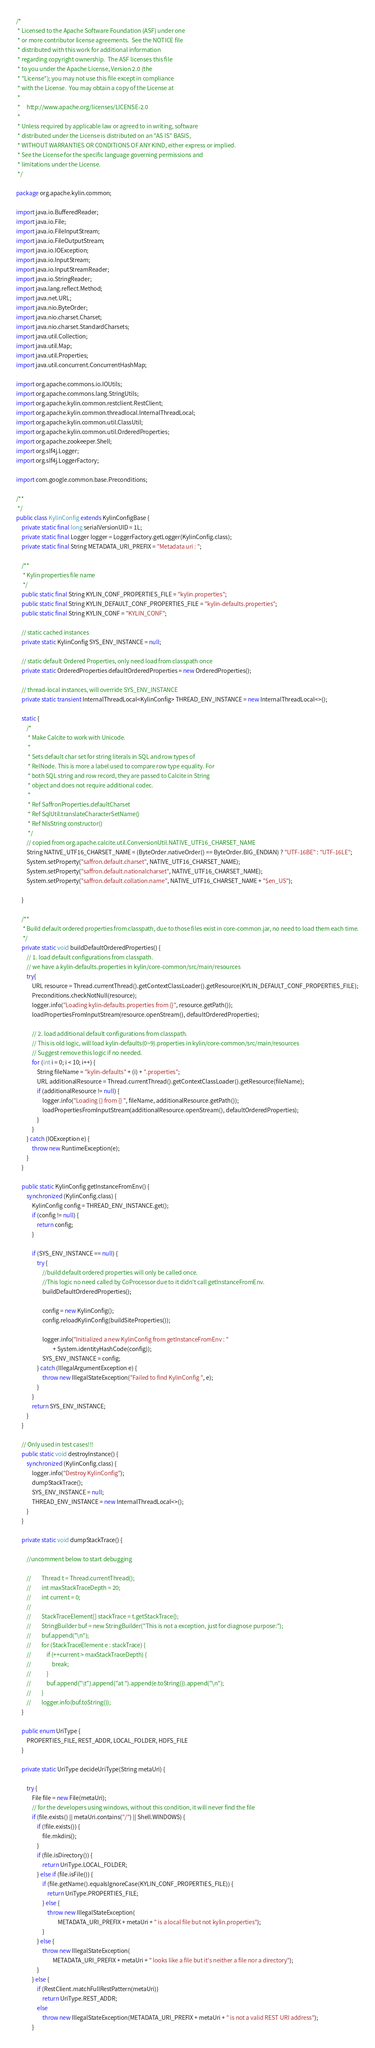<code> <loc_0><loc_0><loc_500><loc_500><_Java_>/*
 * Licensed to the Apache Software Foundation (ASF) under one
 * or more contributor license agreements.  See the NOTICE file
 * distributed with this work for additional information
 * regarding copyright ownership.  The ASF licenses this file
 * to you under the Apache License, Version 2.0 (the
 * "License"); you may not use this file except in compliance
 * with the License.  You may obtain a copy of the License at
 *
 *     http://www.apache.org/licenses/LICENSE-2.0
 *
 * Unless required by applicable law or agreed to in writing, software
 * distributed under the License is distributed on an "AS IS" BASIS,
 * WITHOUT WARRANTIES OR CONDITIONS OF ANY KIND, either express or implied.
 * See the License for the specific language governing permissions and
 * limitations under the License.
 */

package org.apache.kylin.common;

import java.io.BufferedReader;
import java.io.File;
import java.io.FileInputStream;
import java.io.FileOutputStream;
import java.io.IOException;
import java.io.InputStream;
import java.io.InputStreamReader;
import java.io.StringReader;
import java.lang.reflect.Method;
import java.net.URL;
import java.nio.ByteOrder;
import java.nio.charset.Charset;
import java.nio.charset.StandardCharsets;
import java.util.Collection;
import java.util.Map;
import java.util.Properties;
import java.util.concurrent.ConcurrentHashMap;

import org.apache.commons.io.IOUtils;
import org.apache.commons.lang.StringUtils;
import org.apache.kylin.common.restclient.RestClient;
import org.apache.kylin.common.threadlocal.InternalThreadLocal;
import org.apache.kylin.common.util.ClassUtil;
import org.apache.kylin.common.util.OrderedProperties;
import org.apache.zookeeper.Shell;
import org.slf4j.Logger;
import org.slf4j.LoggerFactory;

import com.google.common.base.Preconditions;

/**
 */
public class KylinConfig extends KylinConfigBase {
    private static final long serialVersionUID = 1L;
    private static final Logger logger = LoggerFactory.getLogger(KylinConfig.class);
    private static final String METADATA_URI_PREFIX = "Metadata uri : ";

    /**
     * Kylin properties file name
     */
    public static final String KYLIN_CONF_PROPERTIES_FILE = "kylin.properties";
    public static final String KYLIN_DEFAULT_CONF_PROPERTIES_FILE = "kylin-defaults.properties";
    public static final String KYLIN_CONF = "KYLIN_CONF";

    // static cached instances
    private static KylinConfig SYS_ENV_INSTANCE = null;

    // static default Ordered Properties, only need load from classpath once
    private static OrderedProperties defaultOrderedProperties = new OrderedProperties();

    // thread-local instances, will override SYS_ENV_INSTANCE
    private static transient InternalThreadLocal<KylinConfig> THREAD_ENV_INSTANCE = new InternalThreadLocal<>();

    static {
        /*
         * Make Calcite to work with Unicode.
         *
         * Sets default char set for string literals in SQL and row types of
         * RelNode. This is more a label used to compare row type equality. For
         * both SQL string and row record, they are passed to Calcite in String
         * object and does not require additional codec.
         *
         * Ref SaffronProperties.defaultCharset
         * Ref SqlUtil.translateCharacterSetName()
         * Ref NlsString constructor()
         */
        // copied from org.apache.calcite.util.ConversionUtil.NATIVE_UTF16_CHARSET_NAME
        String NATIVE_UTF16_CHARSET_NAME = (ByteOrder.nativeOrder() == ByteOrder.BIG_ENDIAN) ? "UTF-16BE" : "UTF-16LE";
        System.setProperty("saffron.default.charset", NATIVE_UTF16_CHARSET_NAME);
        System.setProperty("saffron.default.nationalcharset", NATIVE_UTF16_CHARSET_NAME);
        System.setProperty("saffron.default.collation.name", NATIVE_UTF16_CHARSET_NAME + "$en_US");

    }

    /**
     * Build default ordered properties from classpath, due to those files exist in core-common.jar, no need to load them each time.
     */
    private static void buildDefaultOrderedProperties() {
        // 1. load default configurations from classpath.
        // we have a kylin-defaults.properties in kylin/core-common/src/main/resources
        try{
            URL resource = Thread.currentThread().getContextClassLoader().getResource(KYLIN_DEFAULT_CONF_PROPERTIES_FILE);
            Preconditions.checkNotNull(resource);
            logger.info("Loading kylin-defaults.properties from {}", resource.getPath());
            loadPropertiesFromInputStream(resource.openStream(), defaultOrderedProperties);

            // 2. load additional default configurations from classpath.
            // This is old logic, will load kylin-defaults(0~9).properties in kylin/core-common/src/main/resources
            // Suggest remove this logic if no needed.
            for (int i = 0; i < 10; i++) {
                String fileName = "kylin-defaults" + (i) + ".properties";
                URL additionalResource = Thread.currentThread().getContextClassLoader().getResource(fileName);
                if (additionalResource != null) {
                    logger.info("Loading {} from {} ", fileName, additionalResource.getPath());
                    loadPropertiesFromInputStream(additionalResource.openStream(), defaultOrderedProperties);
                }
            }
        } catch (IOException e) {
            throw new RuntimeException(e);
        }
    }

    public static KylinConfig getInstanceFromEnv() {
        synchronized (KylinConfig.class) {
            KylinConfig config = THREAD_ENV_INSTANCE.get();
            if (config != null) {
                return config;
            }

            if (SYS_ENV_INSTANCE == null) {
                try {
                    //build default ordered properties will only be called once.
                    //This logic no need called by CoProcessor due to it didn't call getInstanceFromEnv.
                    buildDefaultOrderedProperties();

                    config = new KylinConfig();
                    config.reloadKylinConfig(buildSiteProperties());

                    logger.info("Initialized a new KylinConfig from getInstanceFromEnv : "
                            + System.identityHashCode(config));
                    SYS_ENV_INSTANCE = config;
                } catch (IllegalArgumentException e) {
                    throw new IllegalStateException("Failed to find KylinConfig ", e);
                }
            }
            return SYS_ENV_INSTANCE;
        }
    }

    // Only used in test cases!!!
    public static void destroyInstance() {
        synchronized (KylinConfig.class) {
            logger.info("Destroy KylinConfig");
            dumpStackTrace();
            SYS_ENV_INSTANCE = null;
            THREAD_ENV_INSTANCE = new InternalThreadLocal<>();
        }
    }

    private static void dumpStackTrace() {

        //uncomment below to start debugging

        //        Thread t = Thread.currentThread();
        //        int maxStackTraceDepth = 20;
        //        int current = 0;
        //
        //        StackTraceElement[] stackTrace = t.getStackTrace();
        //        StringBuilder buf = new StringBuilder("This is not a exception, just for diagnose purpose:");
        //        buf.append("\n");
        //        for (StackTraceElement e : stackTrace) {
        //            if (++current > maxStackTraceDepth) {
        //                break;
        //            }
        //            buf.append("\t").append("at ").append(e.toString()).append("\n");
        //        }
        //        logger.info(buf.toString());
    }

    public enum UriType {
        PROPERTIES_FILE, REST_ADDR, LOCAL_FOLDER, HDFS_FILE
    }

    private static UriType decideUriType(String metaUri) {

        try {
            File file = new File(metaUri);
            // for the developers using windows, without this condition, it will never find the file
            if (file.exists() || metaUri.contains("/") || Shell.WINDOWS) {
                if (!file.exists()) {
                    file.mkdirs();
                }
                if (file.isDirectory()) {
                    return UriType.LOCAL_FOLDER;
                } else if (file.isFile()) {
                    if (file.getName().equalsIgnoreCase(KYLIN_CONF_PROPERTIES_FILE)) {
                        return UriType.PROPERTIES_FILE;
                    } else {
                        throw new IllegalStateException(
                                METADATA_URI_PREFIX + metaUri + " is a local file but not kylin.properties");
                    }
                } else {
                    throw new IllegalStateException(
                            METADATA_URI_PREFIX + metaUri + " looks like a file but it's neither a file nor a directory");
                }
            } else {
                if (RestClient.matchFullRestPattern(metaUri))
                    return UriType.REST_ADDR;
                else
                    throw new IllegalStateException(METADATA_URI_PREFIX + metaUri + " is not a valid REST URI address");
            }</code> 